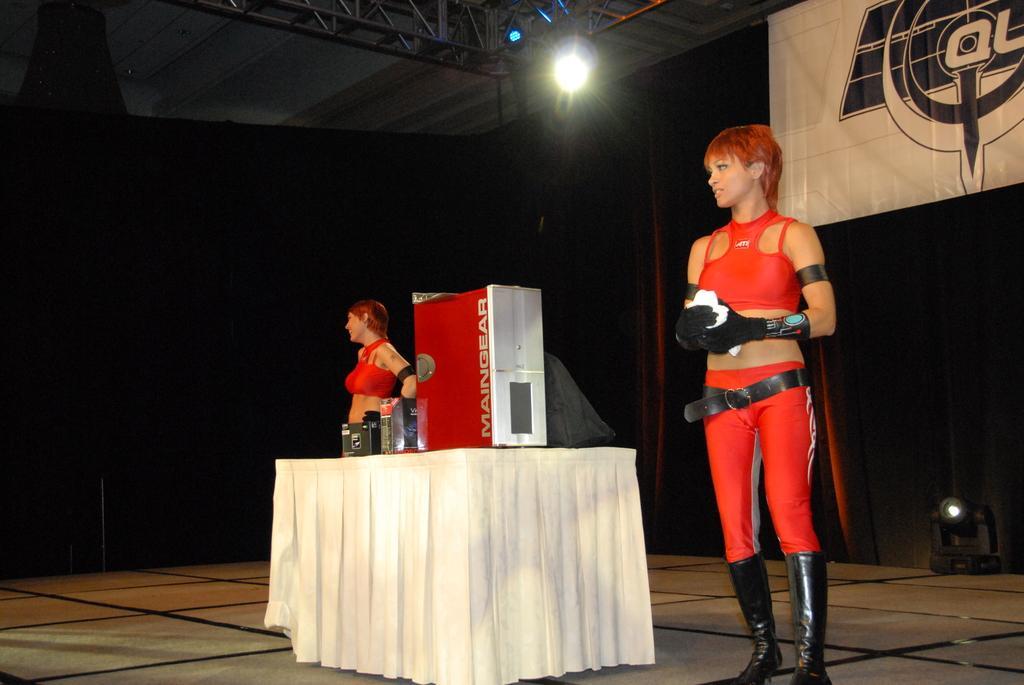In one or two sentences, can you explain what this image depicts? This image consists of two women wearing red dresses are standing on the dais. In the middle, there is a table on which many things are kept along with a box. In the background, we can see the lights and a banner hanged to the roof. At the top, there is a roof along with the stand. At the bottom, there is a dais. 